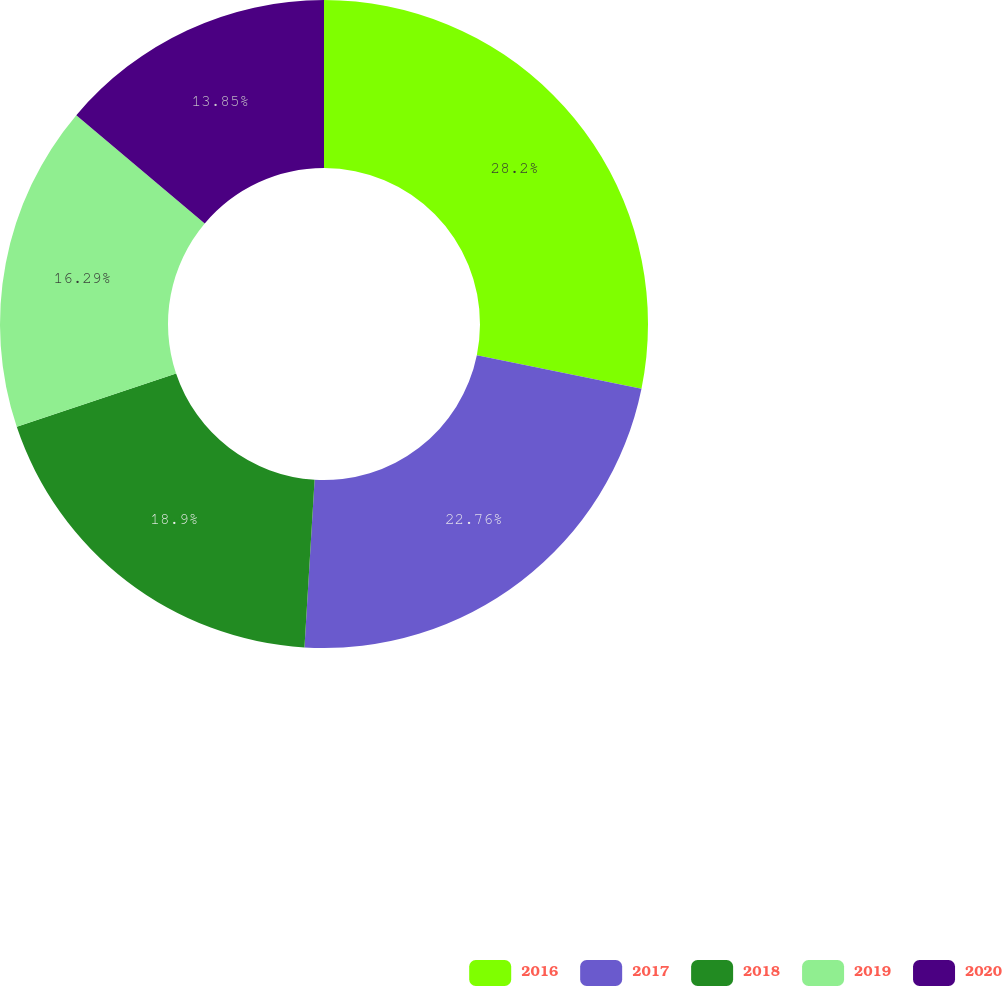Convert chart. <chart><loc_0><loc_0><loc_500><loc_500><pie_chart><fcel>2016<fcel>2017<fcel>2018<fcel>2019<fcel>2020<nl><fcel>28.2%<fcel>22.76%<fcel>18.9%<fcel>16.29%<fcel>13.85%<nl></chart> 